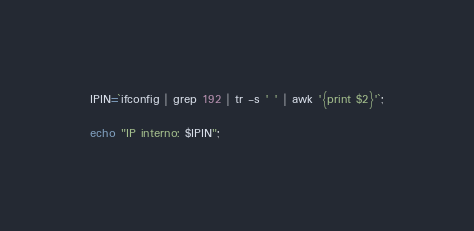<code> <loc_0><loc_0><loc_500><loc_500><_Bash_>IPIN=`ifconfig | grep 192 | tr -s ' ' | awk '{print $2}'`;

echo "IP interno: $IPIN";</code> 